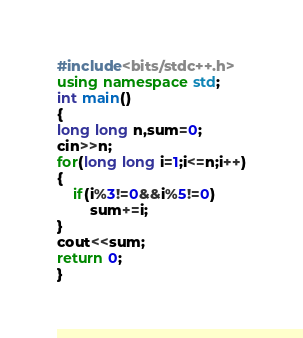<code> <loc_0><loc_0><loc_500><loc_500><_C++_>#include<bits/stdc++.h>
using namespace std;
int main()
{
long long n,sum=0;
cin>>n;
for(long long i=1;i<=n;i++)
{
    if(i%3!=0&&i%5!=0)
        sum+=i;
}
cout<<sum;
return 0;
}
</code> 